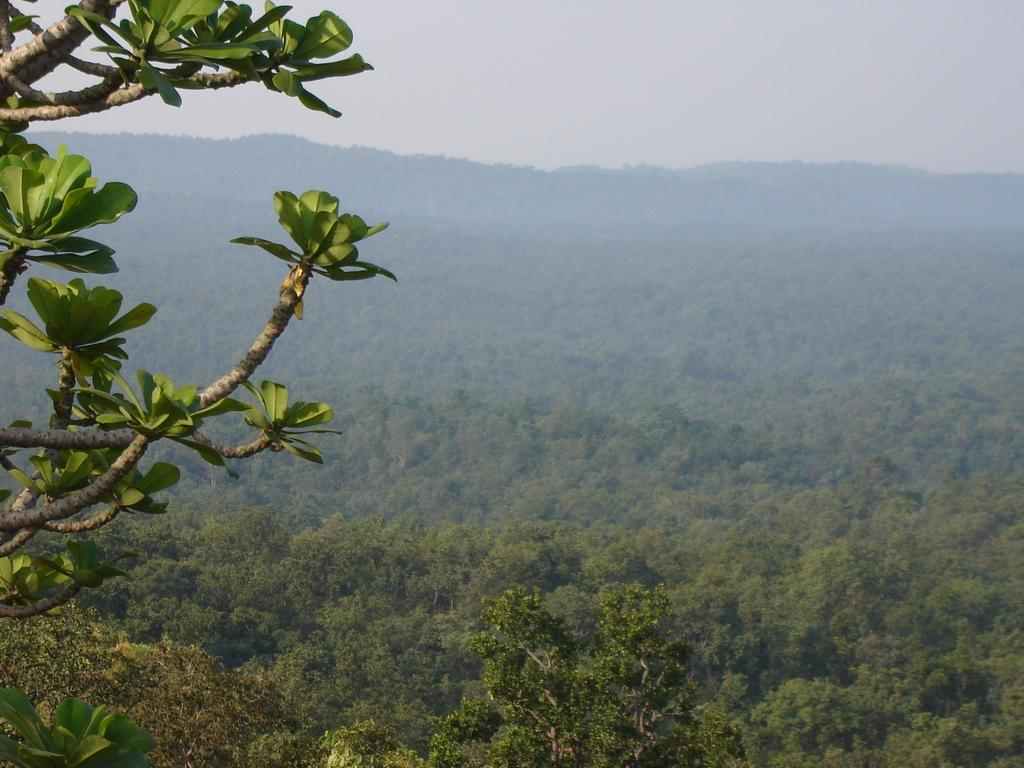What can be seen on the left side of the image? There are leaves and branches of a tree on the left side of the image. What type of environment is depicted in the image? The image appears to depict a forest. What is a common feature of a forest that can be seen in the image? There are trees in the image. What is visible at the top of the image? The sky is visible at the top of the image. Can you tell me where the cup is located in the image? There is no cup present in the image. What type of drink is being served by the porter in the image? There is no porter or drink present in the image. 